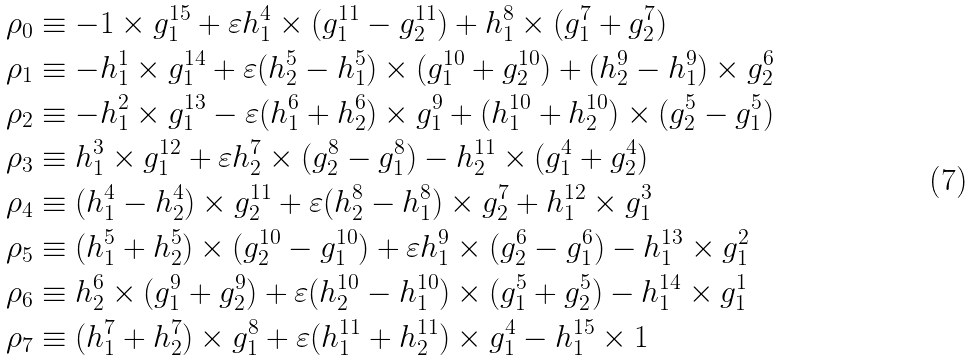Convert formula to latex. <formula><loc_0><loc_0><loc_500><loc_500>\rho _ { 0 } & \equiv - 1 \times g _ { 1 } ^ { 1 5 } + \varepsilon h _ { 1 } ^ { 4 } \times ( g _ { 1 } ^ { 1 1 } - g _ { 2 } ^ { 1 1 } ) + h _ { 1 } ^ { 8 } \times ( g _ { 1 } ^ { 7 } + g _ { 2 } ^ { 7 } ) \\ \rho _ { 1 } & \equiv - h _ { 1 } ^ { 1 } \times g _ { 1 } ^ { 1 4 } + \varepsilon ( h _ { 2 } ^ { 5 } - h _ { 1 } ^ { 5 } ) \times ( g _ { 1 } ^ { 1 0 } + g _ { 2 } ^ { 1 0 } ) + ( h _ { 2 } ^ { 9 } - h _ { 1 } ^ { 9 } ) \times g _ { 2 } ^ { 6 } \\ \rho _ { 2 } & \equiv - h _ { 1 } ^ { 2 } \times g _ { 1 } ^ { 1 3 } - \varepsilon ( h _ { 1 } ^ { 6 } + h _ { 2 } ^ { 6 } ) \times g _ { 1 } ^ { 9 } + ( h _ { 1 } ^ { 1 0 } + h _ { 2 } ^ { 1 0 } ) \times ( g _ { 2 } ^ { 5 } - g _ { 1 } ^ { 5 } ) \\ \rho _ { 3 } & \equiv h _ { 1 } ^ { 3 } \times g _ { 1 } ^ { 1 2 } + \varepsilon h _ { 2 } ^ { 7 } \times ( g _ { 2 } ^ { 8 } - g _ { 1 } ^ { 8 } ) - h _ { 2 } ^ { 1 1 } \times ( g _ { 1 } ^ { 4 } + g _ { 2 } ^ { 4 } ) \\ \rho _ { 4 } & \equiv ( h _ { 1 } ^ { 4 } - h _ { 2 } ^ { 4 } ) \times g _ { 2 } ^ { 1 1 } + \varepsilon ( h _ { 2 } ^ { 8 } - h _ { 1 } ^ { 8 } ) \times g _ { 2 } ^ { 7 } + h _ { 1 } ^ { 1 2 } \times g _ { 1 } ^ { 3 } \\ \rho _ { 5 } & \equiv ( h _ { 1 } ^ { 5 } + h _ { 2 } ^ { 5 } ) \times ( g _ { 2 } ^ { 1 0 } - g _ { 1 } ^ { 1 0 } ) + \varepsilon h _ { 1 } ^ { 9 } \times ( g _ { 2 } ^ { 6 } - g _ { 1 } ^ { 6 } ) - h _ { 1 } ^ { 1 3 } \times g _ { 1 } ^ { 2 } \\ \rho _ { 6 } & \equiv h _ { 2 } ^ { 6 } \times ( g _ { 1 } ^ { 9 } + g _ { 2 } ^ { 9 } ) + \varepsilon ( h _ { 2 } ^ { 1 0 } - h _ { 1 } ^ { 1 0 } ) \times ( g _ { 1 } ^ { 5 } + g _ { 2 } ^ { 5 } ) - h _ { 1 } ^ { 1 4 } \times g _ { 1 } ^ { 1 } \\ \rho _ { 7 } & \equiv ( h _ { 1 } ^ { 7 } + h _ { 2 } ^ { 7 } ) \times g _ { 1 } ^ { 8 } + \varepsilon ( h _ { 1 } ^ { 1 1 } + h _ { 2 } ^ { 1 1 } ) \times g _ { 1 } ^ { 4 } - h _ { 1 } ^ { 1 5 } \times 1</formula> 